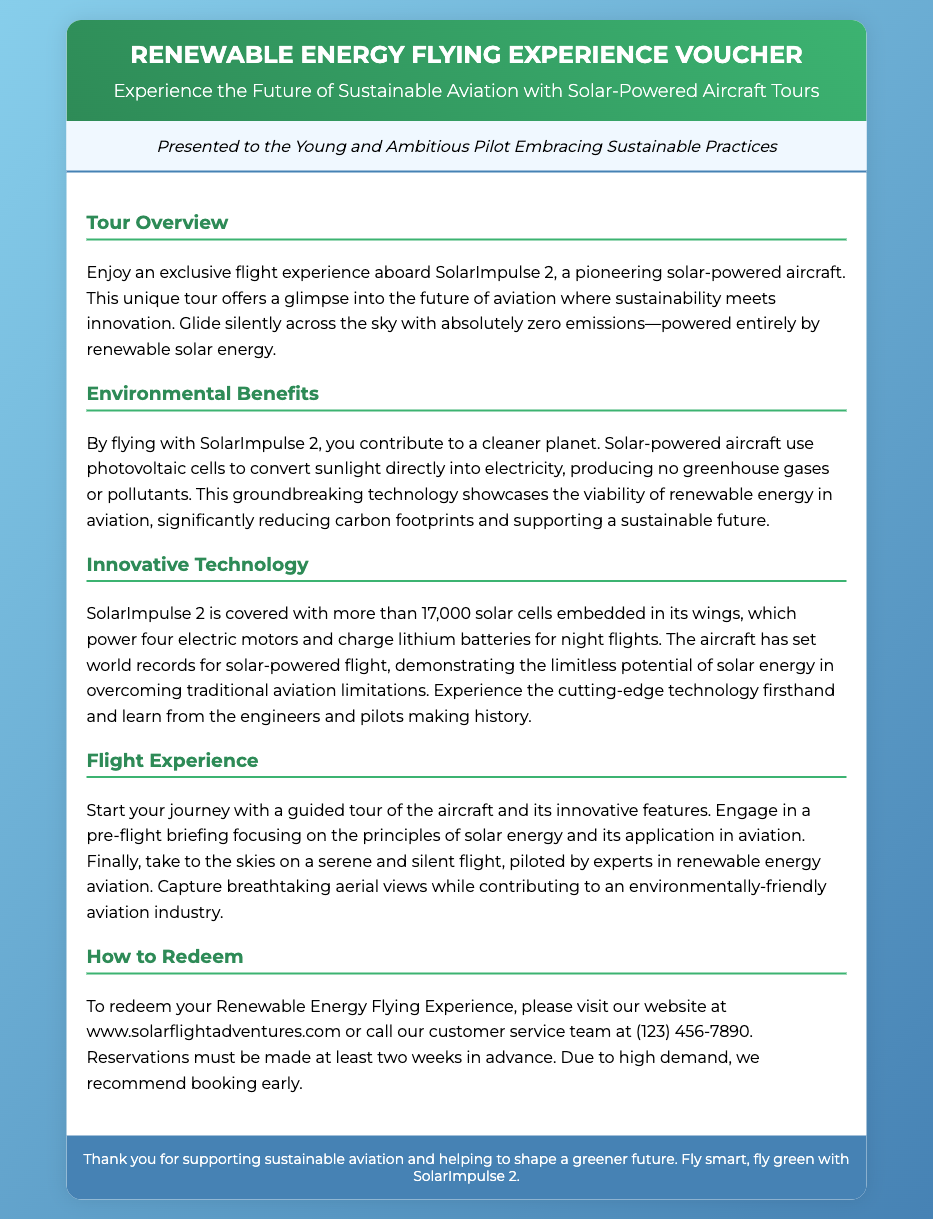What is the title of the voucher? The title is clearly stated at the top of the document, indicating its purpose.
Answer: Renewable Energy Flying Experience Voucher What type of aircraft is used for the tour? The document specifies the aircraft used for the flying experience.
Answer: SolarImpulse 2 How many solar cells does SolarImpulse 2 have? The section on innovative technology mentions the exact number of solar cells.
Answer: More than 17,000 What is required for reservations? The document outlines a specific requirement for booking the flying experience.
Answer: Two weeks in advance What is the environmental status of the flight? The environmental benefits section highlights the key impact of the solar-powered flight.
Answer: Zero emissions What does the guided tour focus on? The flight experience section describes the content of the guided tour.
Answer: Innovative features What is the website for redeeming the voucher? The document clearly provides a website link for further steps in redeeming the voucher.
Answer: www.solarflightadventures.com What color scheme is used in the header? The header's color scheme is described in the document.
Answer: Gradient of green What is the main benefit of flying with SolarImpulse 2? The environmental benefits section outlines a significant advantage of this flying experience.
Answer: Contribute to a cleaner planet 